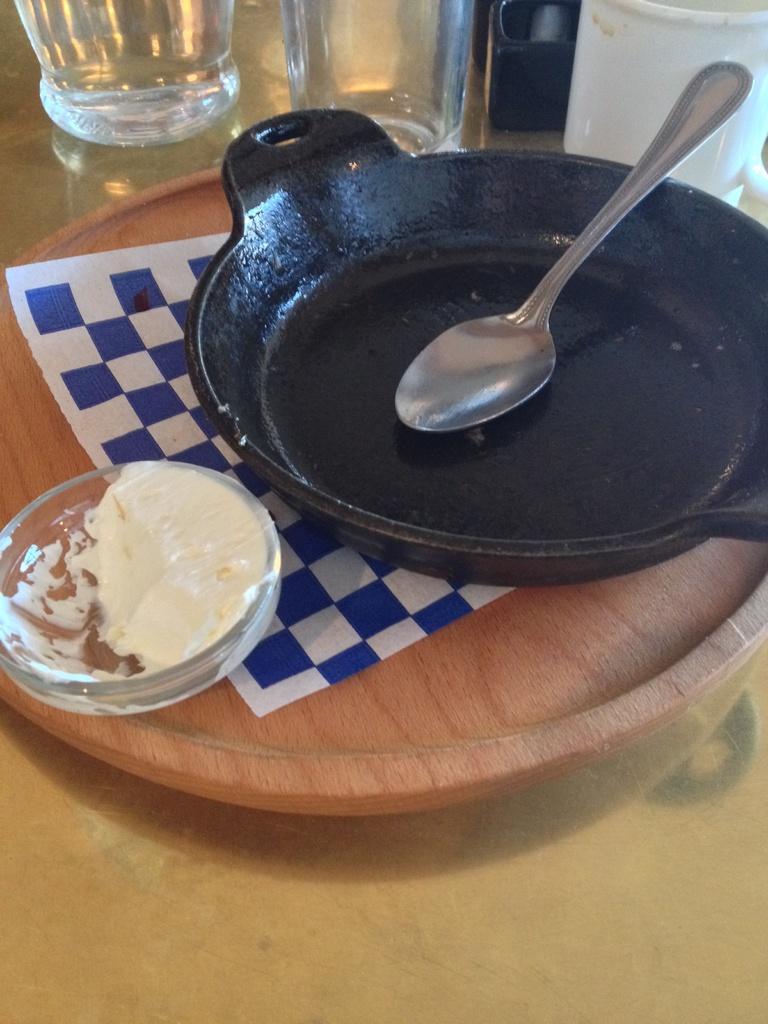In one or two sentences, can you explain what this image depicts? This is a zoomed in picture. In the center there is a table on the top of which a wooden object, a pan, spoon, glasses and some other food items are placed. 